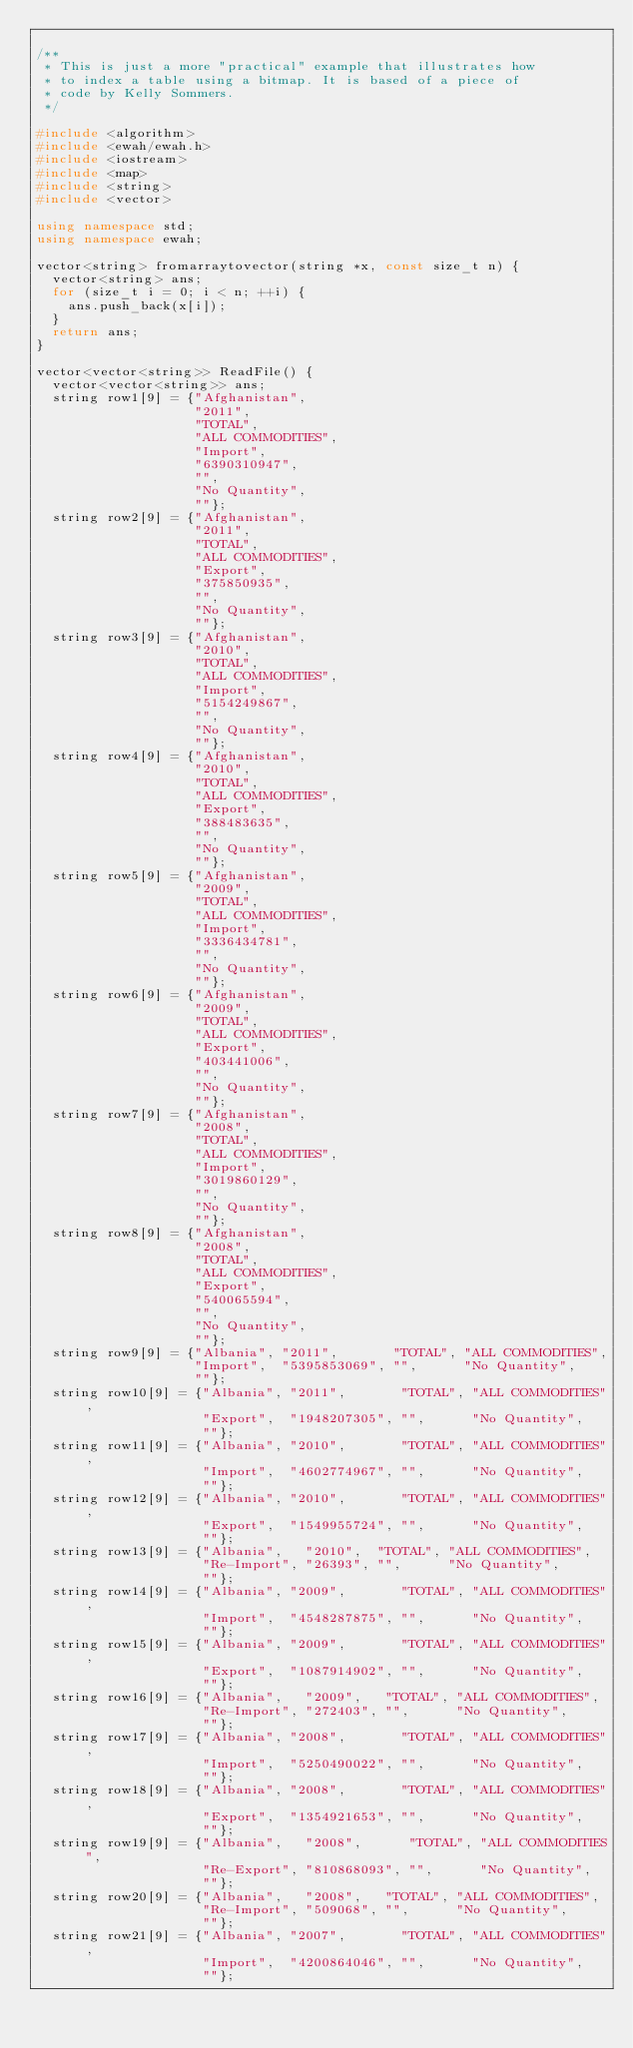Convert code to text. <code><loc_0><loc_0><loc_500><loc_500><_C++_>
/**
 * This is just a more "practical" example that illustrates how
 * to index a table using a bitmap. It is based of a piece of
 * code by Kelly Sommers.
 */

#include <algorithm>
#include <ewah/ewah.h>
#include <iostream>
#include <map>
#include <string>
#include <vector>

using namespace std;
using namespace ewah;

vector<string> fromarraytovector(string *x, const size_t n) {
  vector<string> ans;
  for (size_t i = 0; i < n; ++i) {
    ans.push_back(x[i]);
  }
  return ans;
}

vector<vector<string>> ReadFile() {
  vector<vector<string>> ans;
  string row1[9] = {"Afghanistan",
                    "2011",
                    "TOTAL",
                    "ALL COMMODITIES",
                    "Import",
                    "6390310947",
                    "",
                    "No Quantity",
                    ""};
  string row2[9] = {"Afghanistan",
                    "2011",
                    "TOTAL",
                    "ALL COMMODITIES",
                    "Export",
                    "375850935",
                    "",
                    "No Quantity",
                    ""};
  string row3[9] = {"Afghanistan",
                    "2010",
                    "TOTAL",
                    "ALL COMMODITIES",
                    "Import",
                    "5154249867",
                    "",
                    "No Quantity",
                    ""};
  string row4[9] = {"Afghanistan",
                    "2010",
                    "TOTAL",
                    "ALL COMMODITIES",
                    "Export",
                    "388483635",
                    "",
                    "No Quantity",
                    ""};
  string row5[9] = {"Afghanistan",
                    "2009",
                    "TOTAL",
                    "ALL COMMODITIES",
                    "Import",
                    "3336434781",
                    "",
                    "No Quantity",
                    ""};
  string row6[9] = {"Afghanistan",
                    "2009",
                    "TOTAL",
                    "ALL COMMODITIES",
                    "Export",
                    "403441006",
                    "",
                    "No Quantity",
                    ""};
  string row7[9] = {"Afghanistan",
                    "2008",
                    "TOTAL",
                    "ALL COMMODITIES",
                    "Import",
                    "3019860129",
                    "",
                    "No Quantity",
                    ""};
  string row8[9] = {"Afghanistan",
                    "2008",
                    "TOTAL",
                    "ALL COMMODITIES",
                    "Export",
                    "540065594",
                    "",
                    "No Quantity",
                    ""};
  string row9[9] = {"Albania", "2011",       "TOTAL", "ALL COMMODITIES",
                    "Import",  "5395853069", "",      "No Quantity",
                    ""};
  string row10[9] = {"Albania", "2011",       "TOTAL", "ALL COMMODITIES",
                     "Export",  "1948207305", "",      "No Quantity",
                     ""};
  string row11[9] = {"Albania", "2010",       "TOTAL", "ALL COMMODITIES",
                     "Import",  "4602774967", "",      "No Quantity",
                     ""};
  string row12[9] = {"Albania", "2010",       "TOTAL", "ALL COMMODITIES",
                     "Export",  "1549955724", "",      "No Quantity",
                     ""};
  string row13[9] = {"Albania",   "2010",  "TOTAL", "ALL COMMODITIES",
                     "Re-Import", "26393", "",      "No Quantity",
                     ""};
  string row14[9] = {"Albania", "2009",       "TOTAL", "ALL COMMODITIES",
                     "Import",  "4548287875", "",      "No Quantity",
                     ""};
  string row15[9] = {"Albania", "2009",       "TOTAL", "ALL COMMODITIES",
                     "Export",  "1087914902", "",      "No Quantity",
                     ""};
  string row16[9] = {"Albania",   "2009",   "TOTAL", "ALL COMMODITIES",
                     "Re-Import", "272403", "",      "No Quantity",
                     ""};
  string row17[9] = {"Albania", "2008",       "TOTAL", "ALL COMMODITIES",
                     "Import",  "5250490022", "",      "No Quantity",
                     ""};
  string row18[9] = {"Albania", "2008",       "TOTAL", "ALL COMMODITIES",
                     "Export",  "1354921653", "",      "No Quantity",
                     ""};
  string row19[9] = {"Albania",   "2008",      "TOTAL", "ALL COMMODITIES",
                     "Re-Export", "810868093", "",      "No Quantity",
                     ""};
  string row20[9] = {"Albania",   "2008",   "TOTAL", "ALL COMMODITIES",
                     "Re-Import", "509068", "",      "No Quantity",
                     ""};
  string row21[9] = {"Albania", "2007",       "TOTAL", "ALL COMMODITIES",
                     "Import",  "4200864046", "",      "No Quantity",
                     ""};</code> 